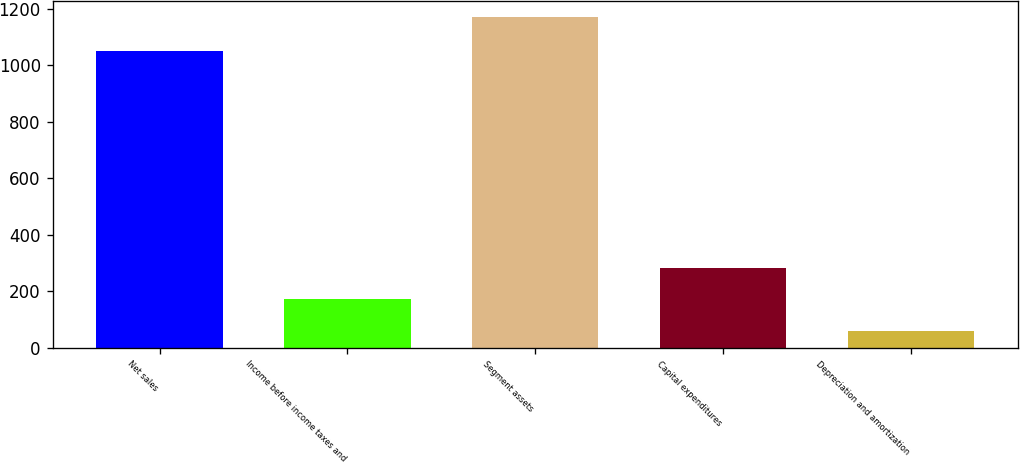Convert chart. <chart><loc_0><loc_0><loc_500><loc_500><bar_chart><fcel>Net sales<fcel>Income before income taxes and<fcel>Segment assets<fcel>Capital expenditures<fcel>Depreciation and amortization<nl><fcel>1051.1<fcel>171.41<fcel>1168.7<fcel>282.22<fcel>60.6<nl></chart> 